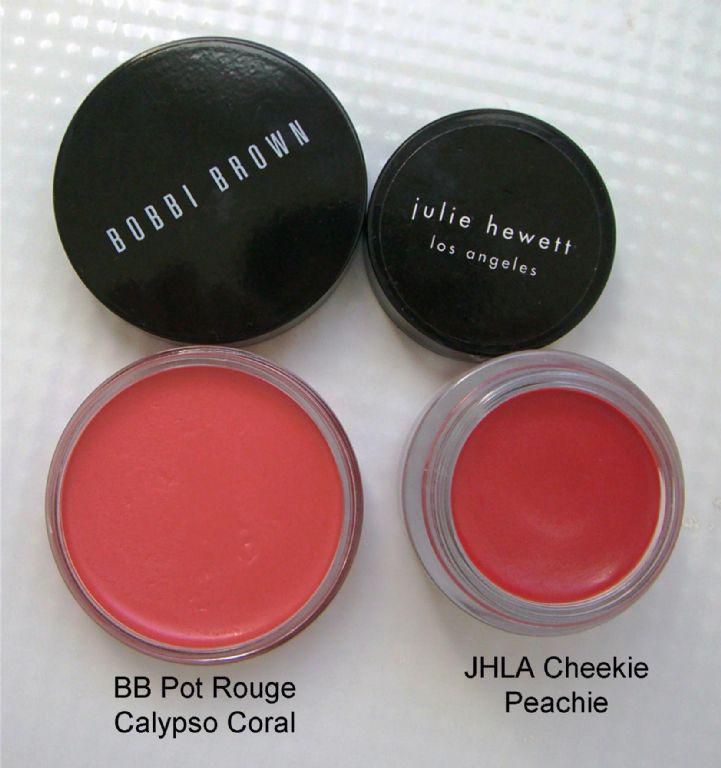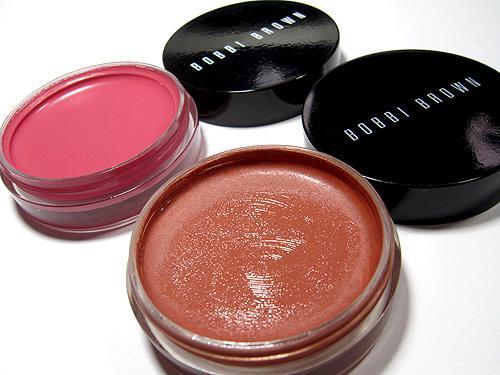The first image is the image on the left, the second image is the image on the right. Given the left and right images, does the statement "Each image contains exactly four round disc-shaped items." hold true? Answer yes or no. Yes. The first image is the image on the left, the second image is the image on the right. Considering the images on both sides, is "There are two open makeup with their lids next to them in the right image." valid? Answer yes or no. Yes. 